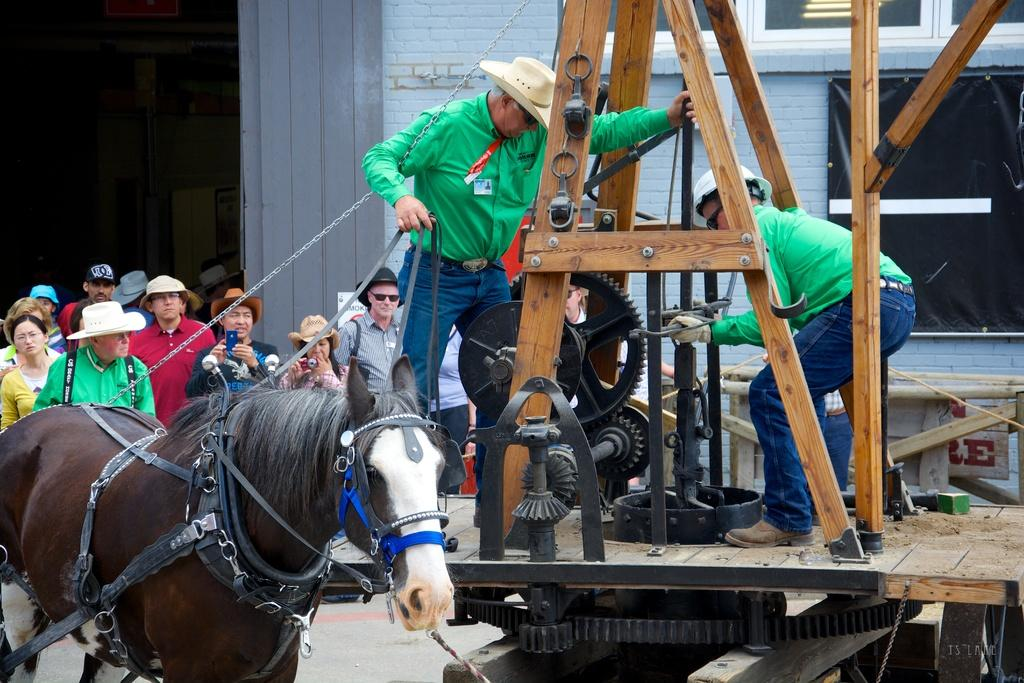What animal is present in the image? There is a horse in the image. What can be seen on the right side of the image? There is a machine on the right side of the image. What are the two persons doing on the machine? The two persons are standing on the machine. What is visible in the background of the image? There are people standing in the background of the image and a building. What type of health benefits can be gained from the icicle hanging from the horse's mouth in the image? There is no icicle present in the image, and therefore no health benefits can be gained from it. 